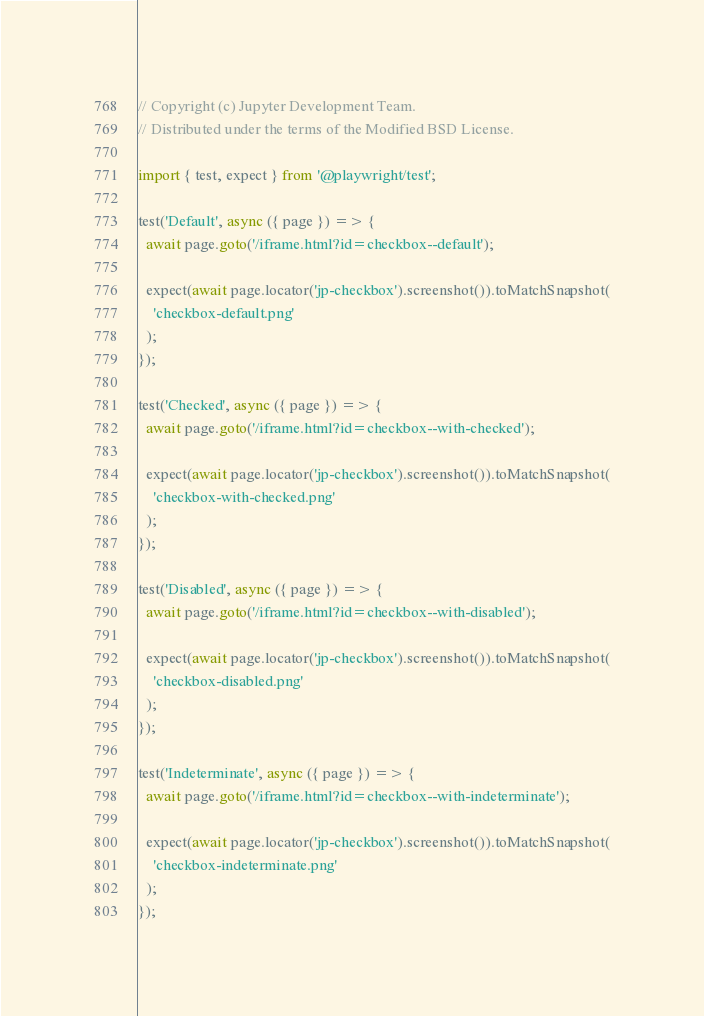Convert code to text. <code><loc_0><loc_0><loc_500><loc_500><_TypeScript_>// Copyright (c) Jupyter Development Team.
// Distributed under the terms of the Modified BSD License.

import { test, expect } from '@playwright/test';

test('Default', async ({ page }) => {
  await page.goto('/iframe.html?id=checkbox--default');

  expect(await page.locator('jp-checkbox').screenshot()).toMatchSnapshot(
    'checkbox-default.png'
  );
});

test('Checked', async ({ page }) => {
  await page.goto('/iframe.html?id=checkbox--with-checked');

  expect(await page.locator('jp-checkbox').screenshot()).toMatchSnapshot(
    'checkbox-with-checked.png'
  );
});

test('Disabled', async ({ page }) => {
  await page.goto('/iframe.html?id=checkbox--with-disabled');

  expect(await page.locator('jp-checkbox').screenshot()).toMatchSnapshot(
    'checkbox-disabled.png'
  );
});

test('Indeterminate', async ({ page }) => {
  await page.goto('/iframe.html?id=checkbox--with-indeterminate');

  expect(await page.locator('jp-checkbox').screenshot()).toMatchSnapshot(
    'checkbox-indeterminate.png'
  );
});
</code> 